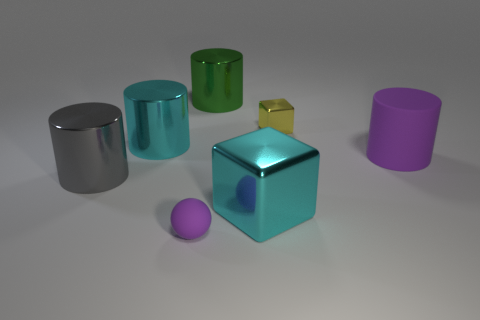Add 1 tiny cyan metallic cubes. How many objects exist? 8 Subtract all spheres. How many objects are left? 6 Add 6 small cyan metallic spheres. How many small cyan metallic spheres exist? 6 Subtract 1 cyan cylinders. How many objects are left? 6 Subtract all purple spheres. Subtract all large red things. How many objects are left? 6 Add 1 large gray cylinders. How many large gray cylinders are left? 2 